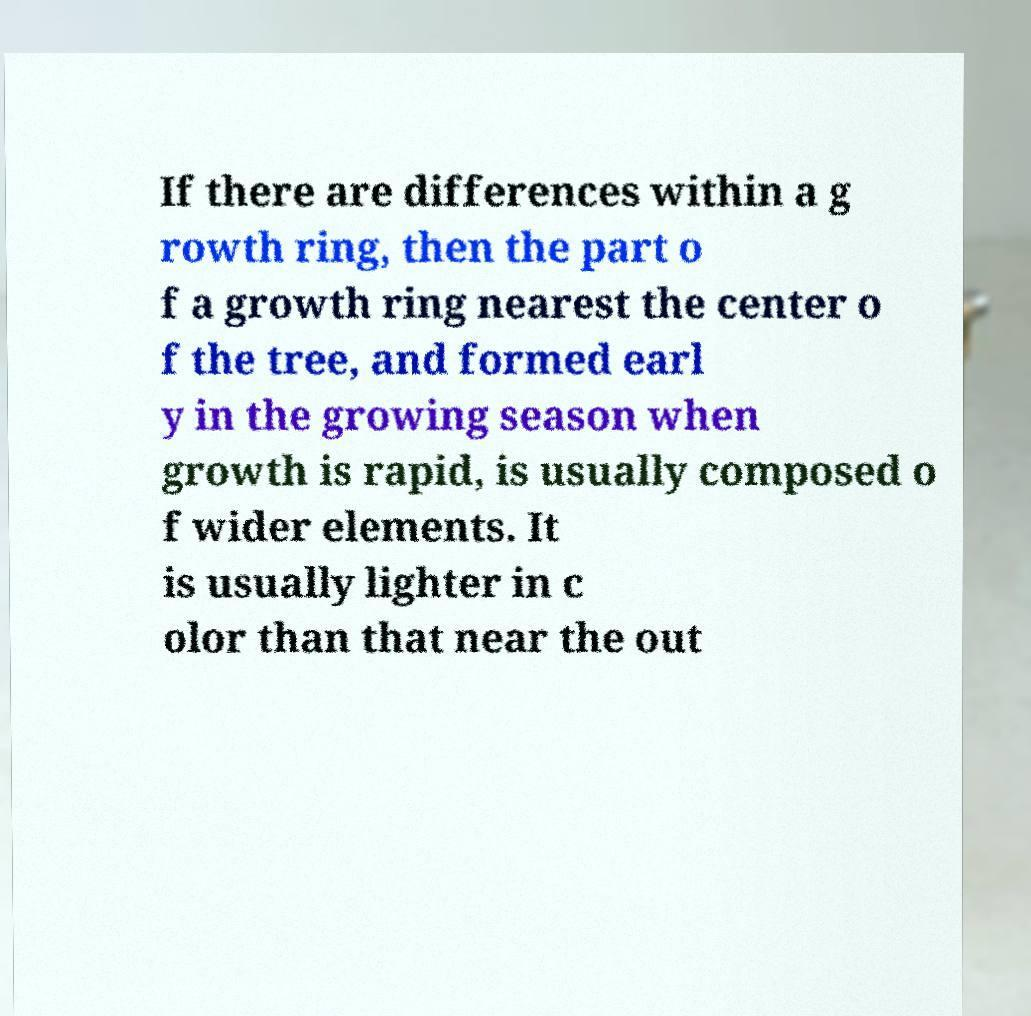Could you assist in decoding the text presented in this image and type it out clearly? If there are differences within a g rowth ring, then the part o f a growth ring nearest the center o f the tree, and formed earl y in the growing season when growth is rapid, is usually composed o f wider elements. It is usually lighter in c olor than that near the out 